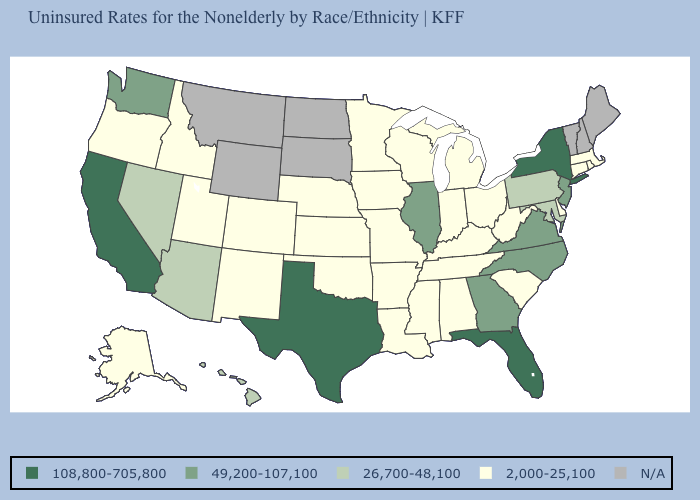What is the value of Iowa?
Be succinct. 2,000-25,100. Does California have the highest value in the USA?
Be succinct. Yes. What is the value of Arizona?
Keep it brief. 26,700-48,100. Among the states that border Nevada , which have the lowest value?
Write a very short answer. Idaho, Oregon, Utah. Does Arkansas have the highest value in the South?
Write a very short answer. No. Is the legend a continuous bar?
Short answer required. No. What is the lowest value in the USA?
Be succinct. 2,000-25,100. Name the states that have a value in the range 108,800-705,800?
Write a very short answer. California, Florida, New York, Texas. Name the states that have a value in the range N/A?
Give a very brief answer. Maine, Montana, New Hampshire, North Dakota, South Dakota, Vermont, Wyoming. Name the states that have a value in the range 108,800-705,800?
Give a very brief answer. California, Florida, New York, Texas. What is the highest value in the USA?
Keep it brief. 108,800-705,800. Which states have the lowest value in the USA?
Give a very brief answer. Alabama, Alaska, Arkansas, Colorado, Connecticut, Delaware, Idaho, Indiana, Iowa, Kansas, Kentucky, Louisiana, Massachusetts, Michigan, Minnesota, Mississippi, Missouri, Nebraska, New Mexico, Ohio, Oklahoma, Oregon, Rhode Island, South Carolina, Tennessee, Utah, West Virginia, Wisconsin. 